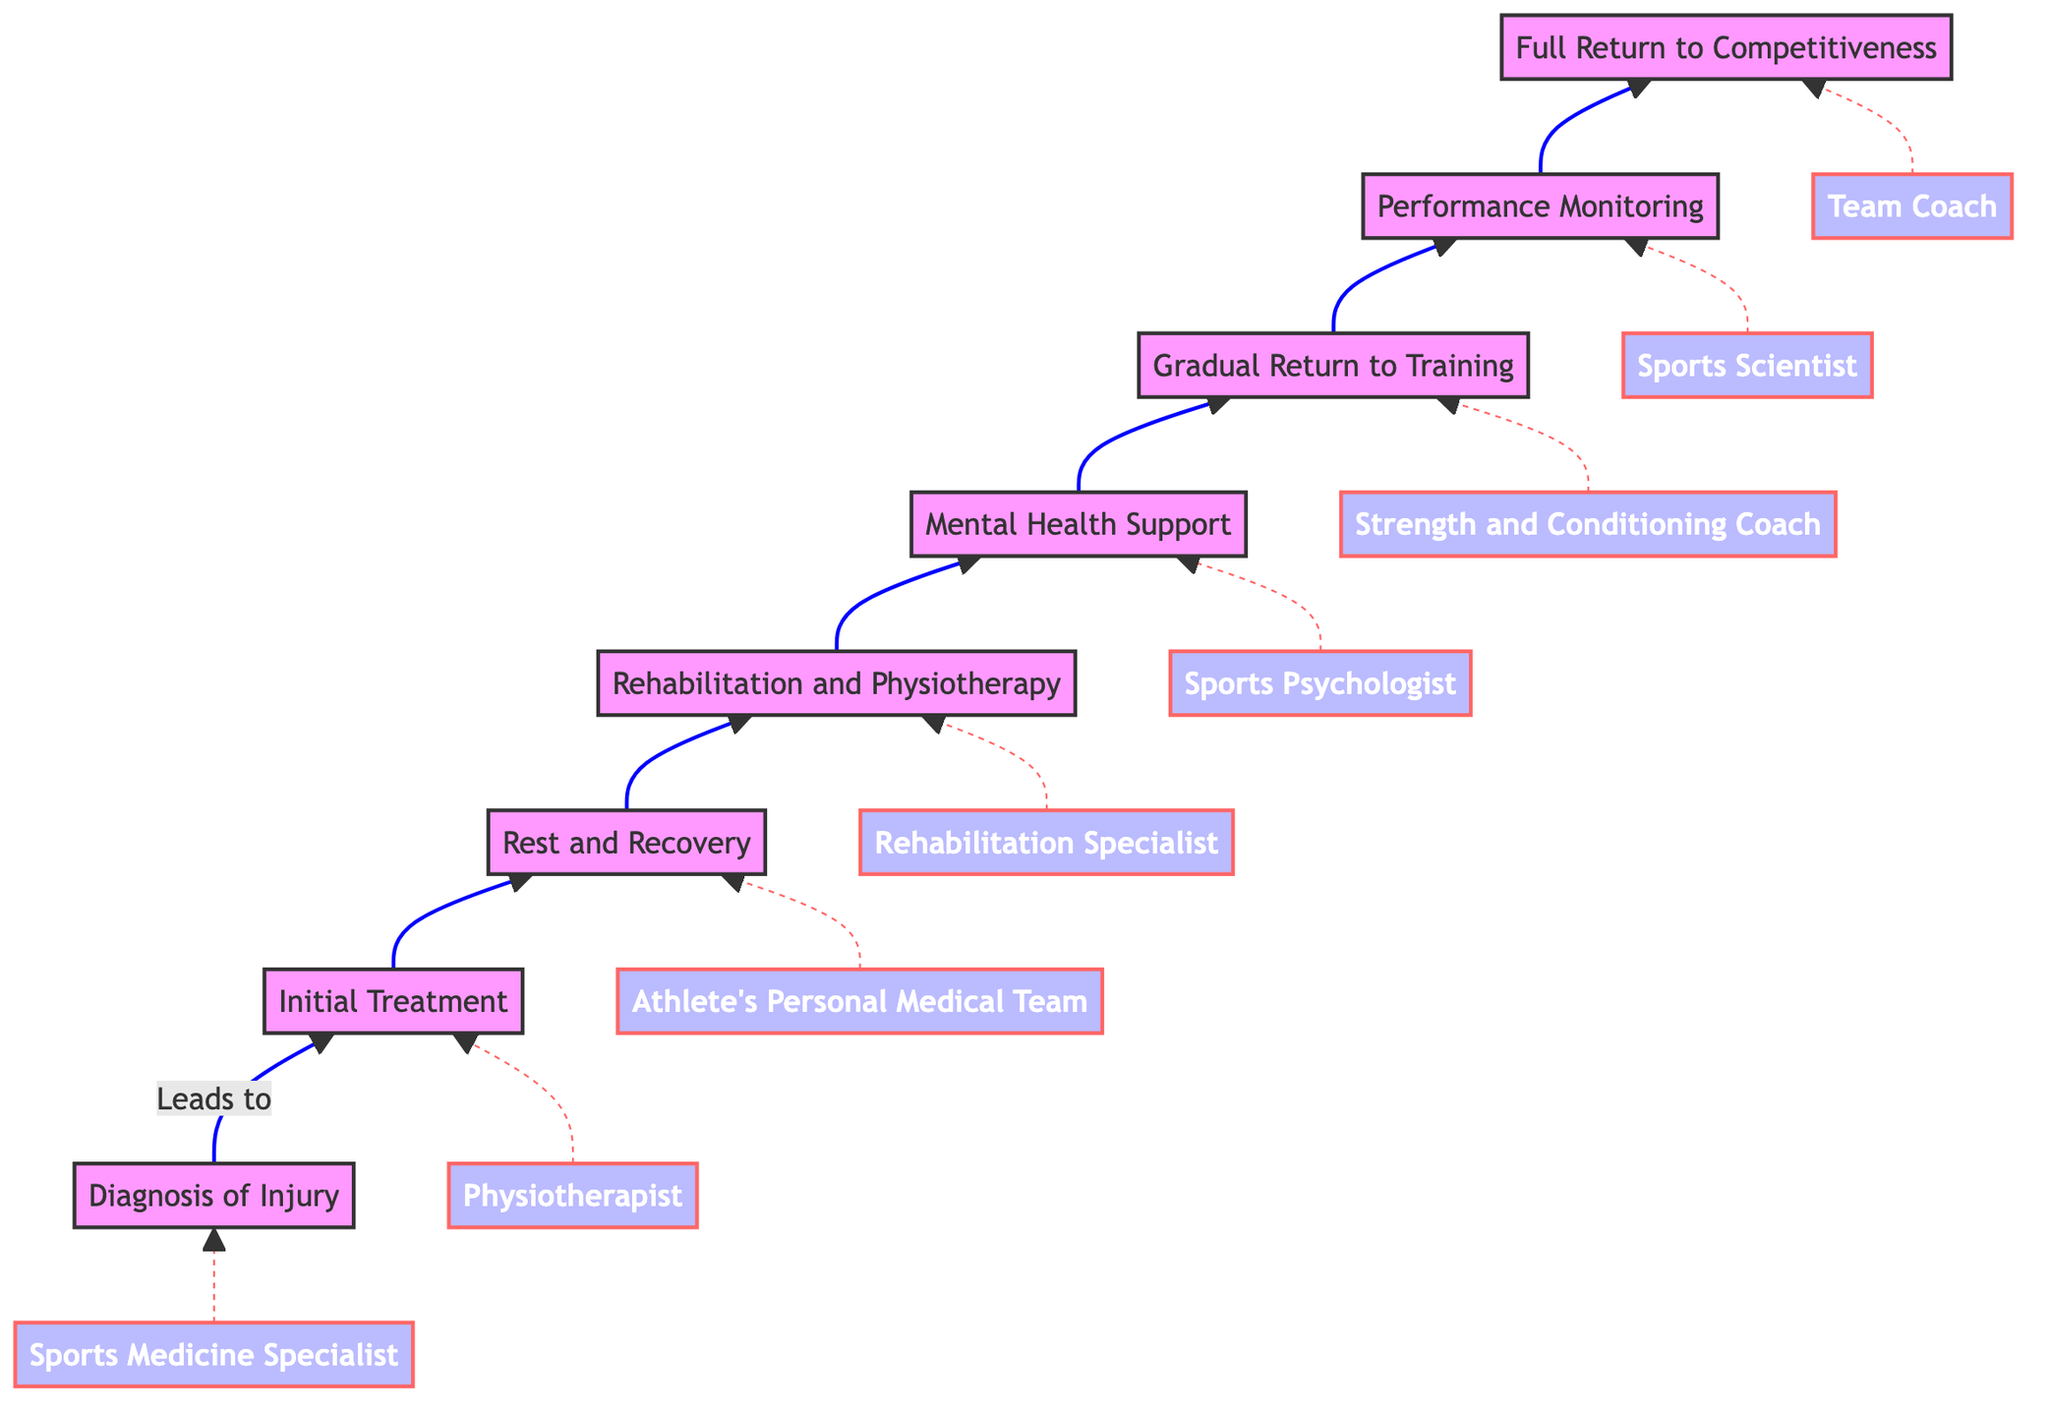What is the first step in the recovery process? The first step in the recovery process, according to the diagram, is "Diagnosis of Injury," which leads into the next step.
Answer: Diagnosis of Injury How many total steps are there in the recovery process? By counting the nodes in the flow chart, there are 8 steps listed, starting from "Diagnosis of Injury" to "Full Return to Competitiveness."
Answer: 8 Who provides the "Initial Treatment"? The "Initial Treatment" step is supported by "Physiotherapist," as indicated in the diagram with a dashed line.
Answer: Physiotherapist What is the final outcome of the recovery process? The flow chart indicates that the final outcome, or the last step, is "Full Return to Competitiveness."
Answer: Full Return to Competitiveness What supports the "Rehabilitation and Physiotherapy" step? The step "Rehabilitation and Physiotherapy" is supported by "Rehabilitation Specialist," which is clearly specified in the diagram.
Answer: Rehabilitation Specialist What is the relationship between "Mental Health Support" and "Gradual Return to Training"? "Mental Health Support" leads directly into "Gradual Return to Training," indicating that mental support is a prerequisite before returning to training.
Answer: Leads to Which entity supports "Performance Monitoring"? The supporting entity for "Performance Monitoring" is stated clearly in the diagram as "Sports Scientist."
Answer: Sports Scientist What type of support is provided before returning to training? Before returning to training, the athlete receives "Mental Health Support," indicating the importance of psychological readiness prior to physical activity.
Answer: Mental Health Support What is the immediate prerequisite for "Rest and Recovery"? According to the diagram, the immediate prerequisite for "Rest and Recovery" is "Initial Treatment," indicating that treatment must occur first.
Answer: Initial Treatment 